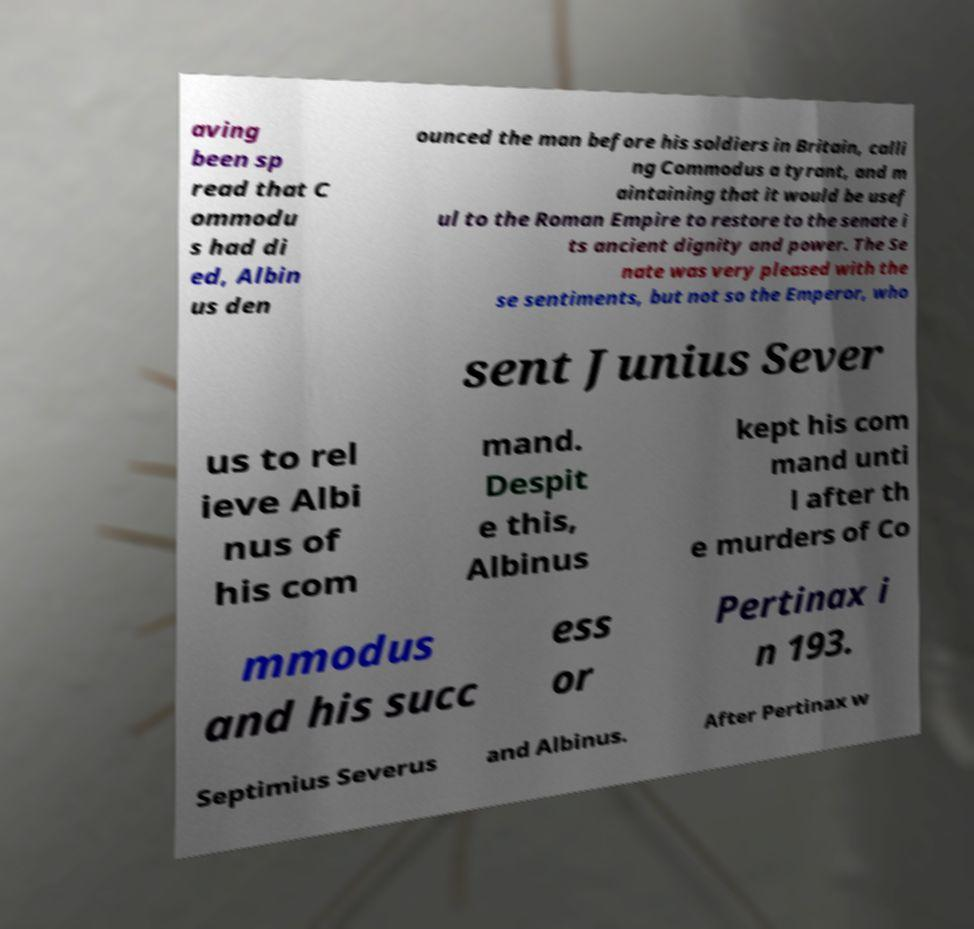Please identify and transcribe the text found in this image. aving been sp read that C ommodu s had di ed, Albin us den ounced the man before his soldiers in Britain, calli ng Commodus a tyrant, and m aintaining that it would be usef ul to the Roman Empire to restore to the senate i ts ancient dignity and power. The Se nate was very pleased with the se sentiments, but not so the Emperor, who sent Junius Sever us to rel ieve Albi nus of his com mand. Despit e this, Albinus kept his com mand unti l after th e murders of Co mmodus and his succ ess or Pertinax i n 193. Septimius Severus and Albinus. After Pertinax w 